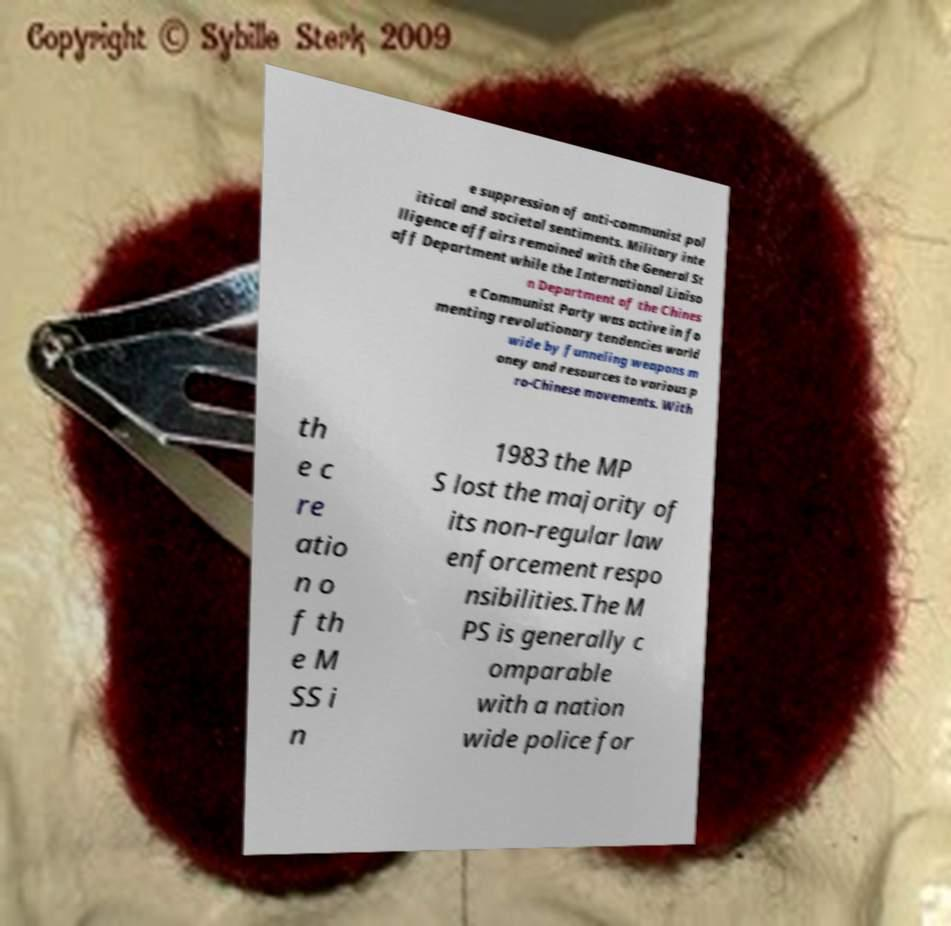I need the written content from this picture converted into text. Can you do that? e suppression of anti-communist pol itical and societal sentiments. Military inte lligence affairs remained with the General St aff Department while the International Liaiso n Department of the Chines e Communist Party was active in fo menting revolutionary tendencies world wide by funneling weapons m oney and resources to various p ro-Chinese movements. With th e c re atio n o f th e M SS i n 1983 the MP S lost the majority of its non-regular law enforcement respo nsibilities.The M PS is generally c omparable with a nation wide police for 